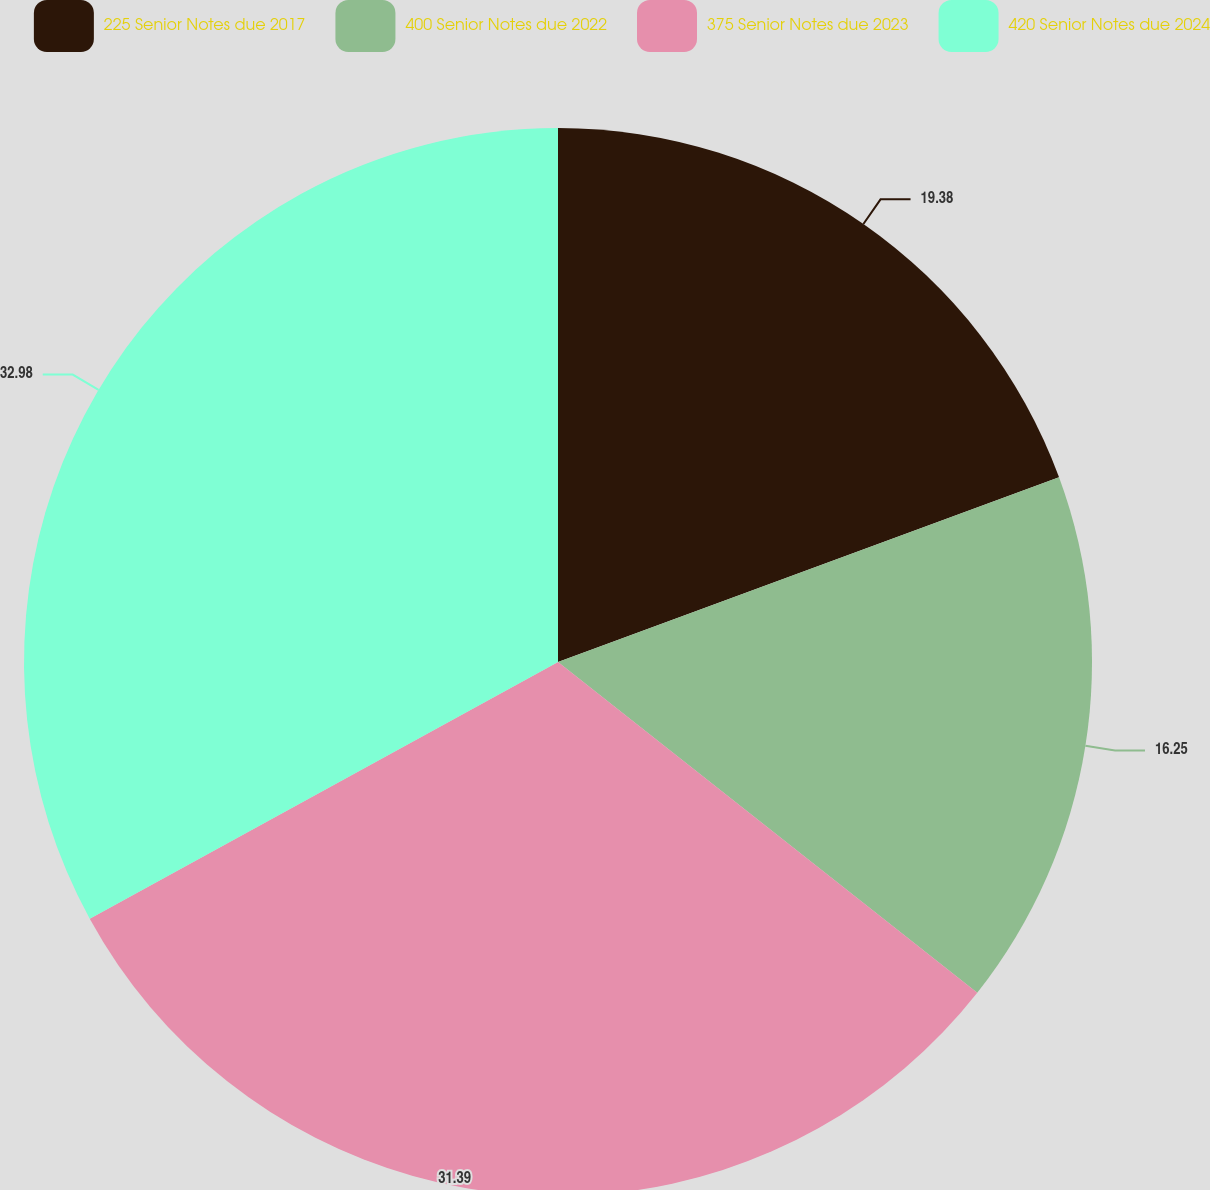<chart> <loc_0><loc_0><loc_500><loc_500><pie_chart><fcel>225 Senior Notes due 2017<fcel>400 Senior Notes due 2022<fcel>375 Senior Notes due 2023<fcel>420 Senior Notes due 2024<nl><fcel>19.38%<fcel>16.25%<fcel>31.39%<fcel>32.98%<nl></chart> 